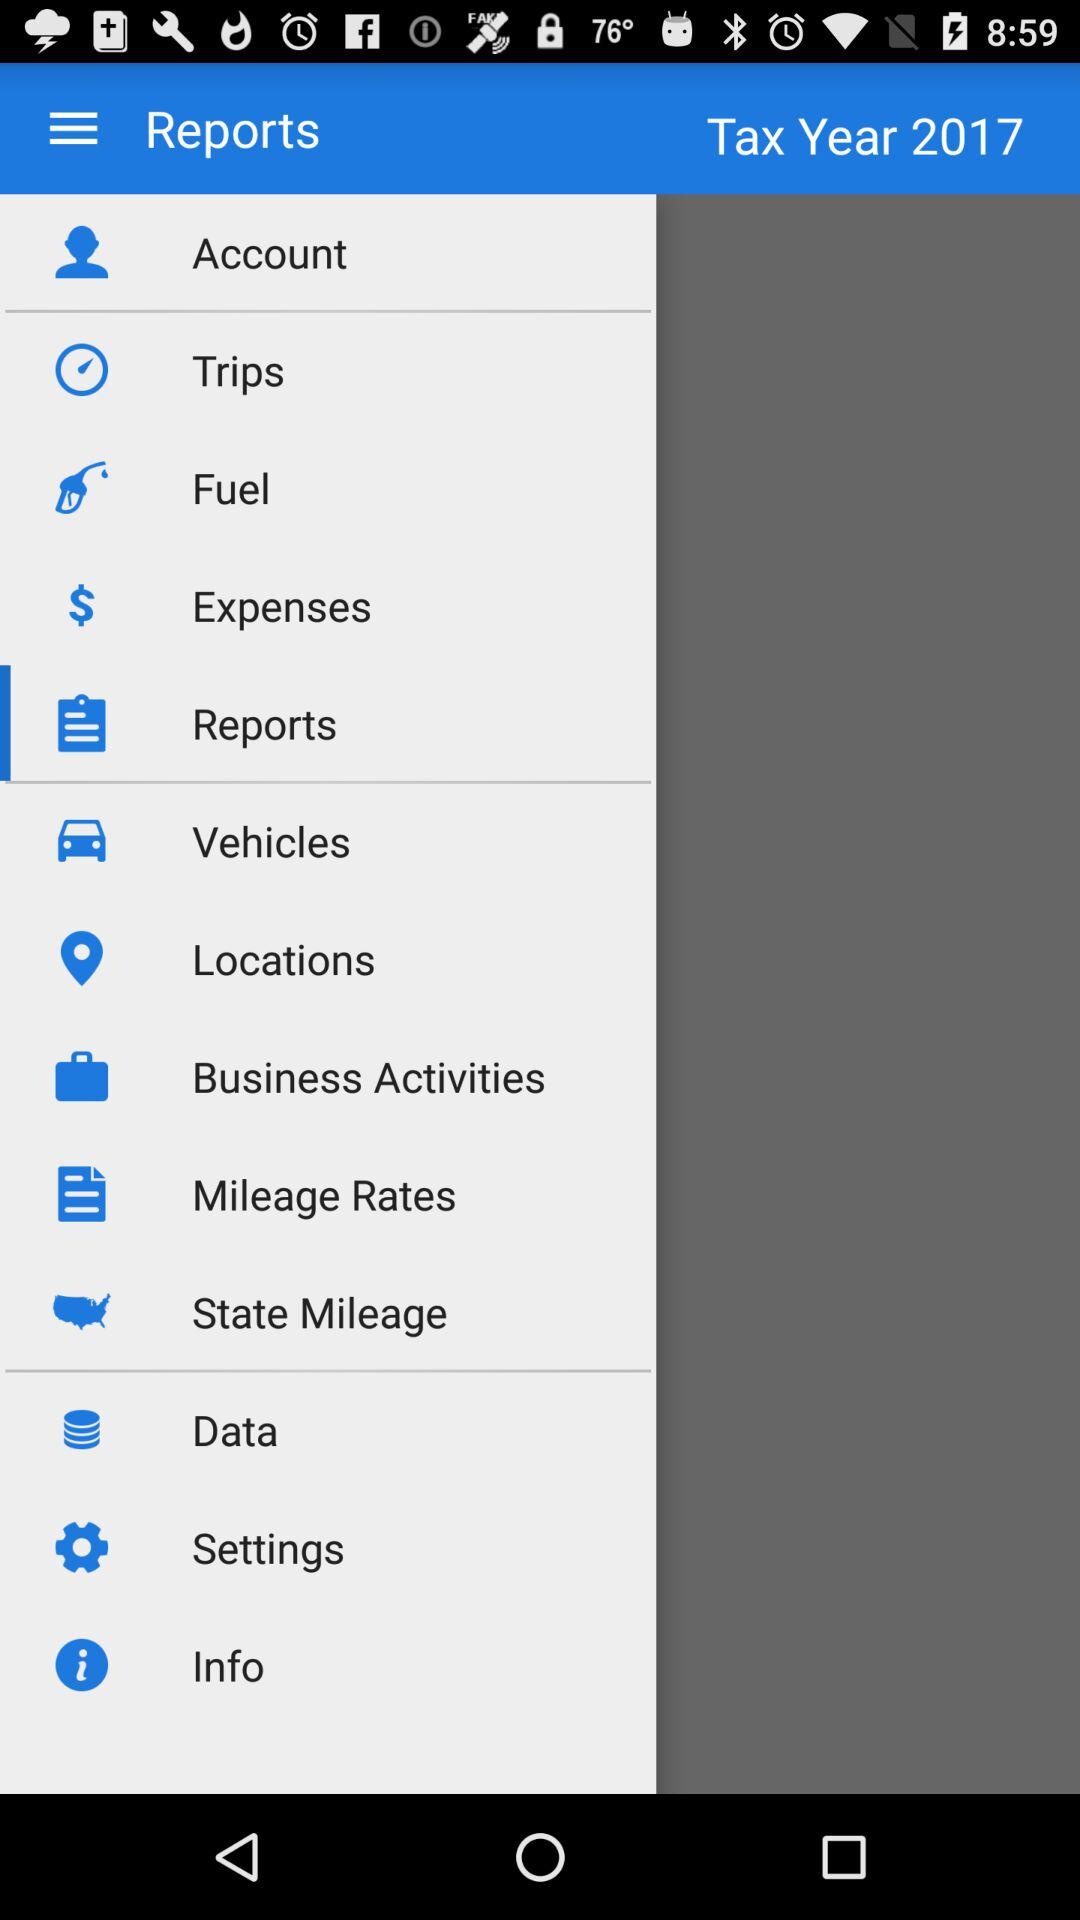What is the tax year? The tax year is 2017. 